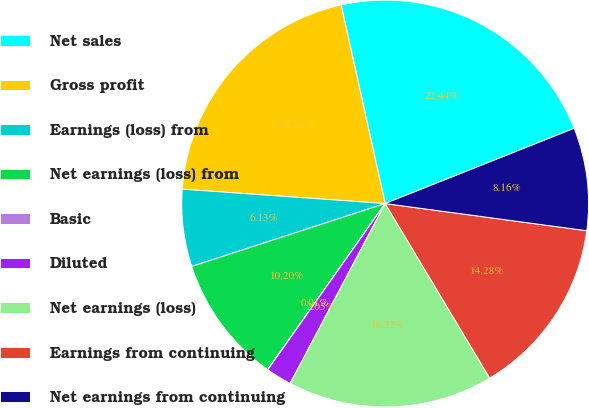Convert chart. <chart><loc_0><loc_0><loc_500><loc_500><pie_chart><fcel>Net sales<fcel>Gross profit<fcel>Earnings (loss) from<fcel>Net earnings (loss) from<fcel>Basic<fcel>Diluted<fcel>Net earnings (loss)<fcel>Earnings from continuing<fcel>Net earnings from continuing<nl><fcel>22.44%<fcel>20.4%<fcel>6.13%<fcel>10.2%<fcel>0.01%<fcel>2.05%<fcel>16.32%<fcel>14.28%<fcel>8.16%<nl></chart> 